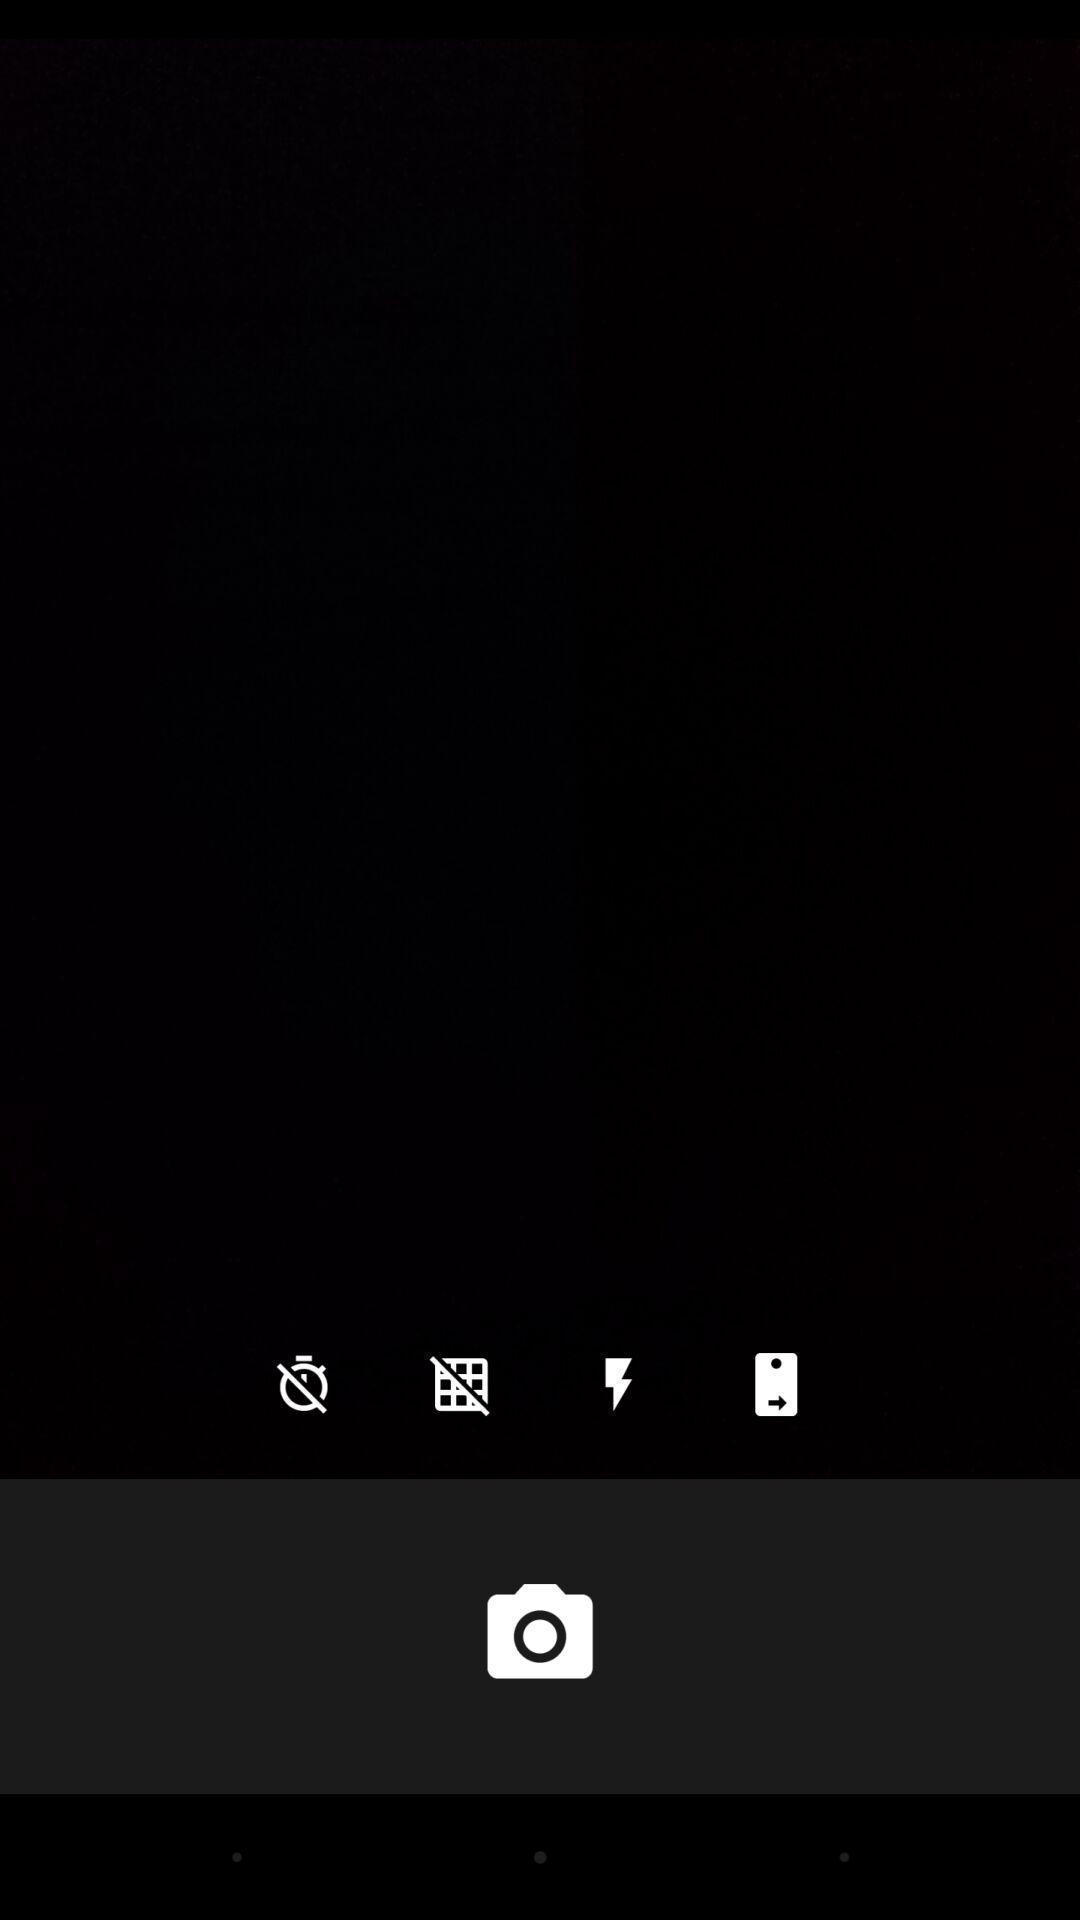What can you discern from this picture? Screen displaying multiple control options and a camera icon. 